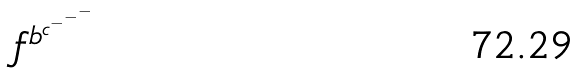Convert formula to latex. <formula><loc_0><loc_0><loc_500><loc_500>f ^ { b ^ { c ^ { - ^ { - ^ { - } } } } }</formula> 